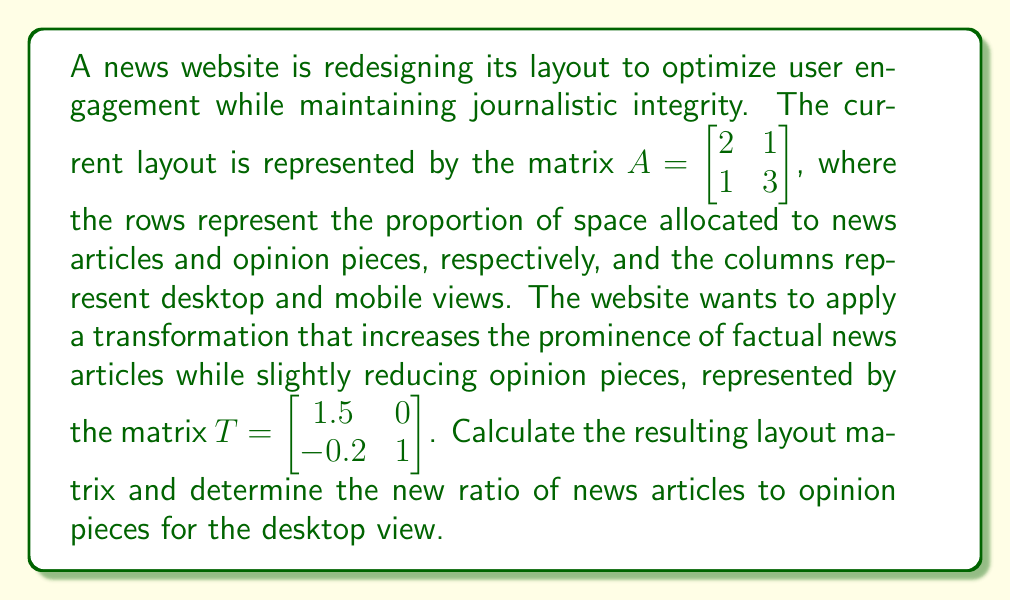What is the answer to this math problem? To solve this problem, we need to follow these steps:

1. Multiply the transformation matrix $T$ by the current layout matrix $A$:

   $$B = T \cdot A = \begin{bmatrix} 1.5 & 0 \\ -0.2 & 1 \end{bmatrix} \cdot \begin{bmatrix} 2 & 1 \\ 1 & 3 \end{bmatrix}$$

2. Perform the matrix multiplication:

   $$B = \begin{bmatrix} (1.5 \cdot 2 + 0 \cdot 1) & (1.5 \cdot 1 + 0 \cdot 3) \\ (-0.2 \cdot 2 + 1 \cdot 1) & (-0.2 \cdot 1 + 1 \cdot 3) \end{bmatrix}$$

   $$B = \begin{bmatrix} 3 & 1.5 \\ 0.6 & 2.8 \end{bmatrix}$$

3. The resulting layout matrix $B$ shows the new proportions for news articles and opinion pieces for both desktop and mobile views.

4. To find the ratio of news articles to opinion pieces for the desktop view, we look at the first column of matrix $B$:

   News articles: 3
   Opinion pieces: 0.6

   Ratio = $3 : 0.6 = 5 : 1$

This ratio can be simplified to 5:1, meaning for every 5 units of space allocated to news articles, 1 unit is allocated to opinion pieces in the desktop view.
Answer: The new layout matrix is $B = \begin{bmatrix} 3 & 1.5 \\ 0.6 & 2.8 \end{bmatrix}$, and the ratio of news articles to opinion pieces for the desktop view is 5:1. 